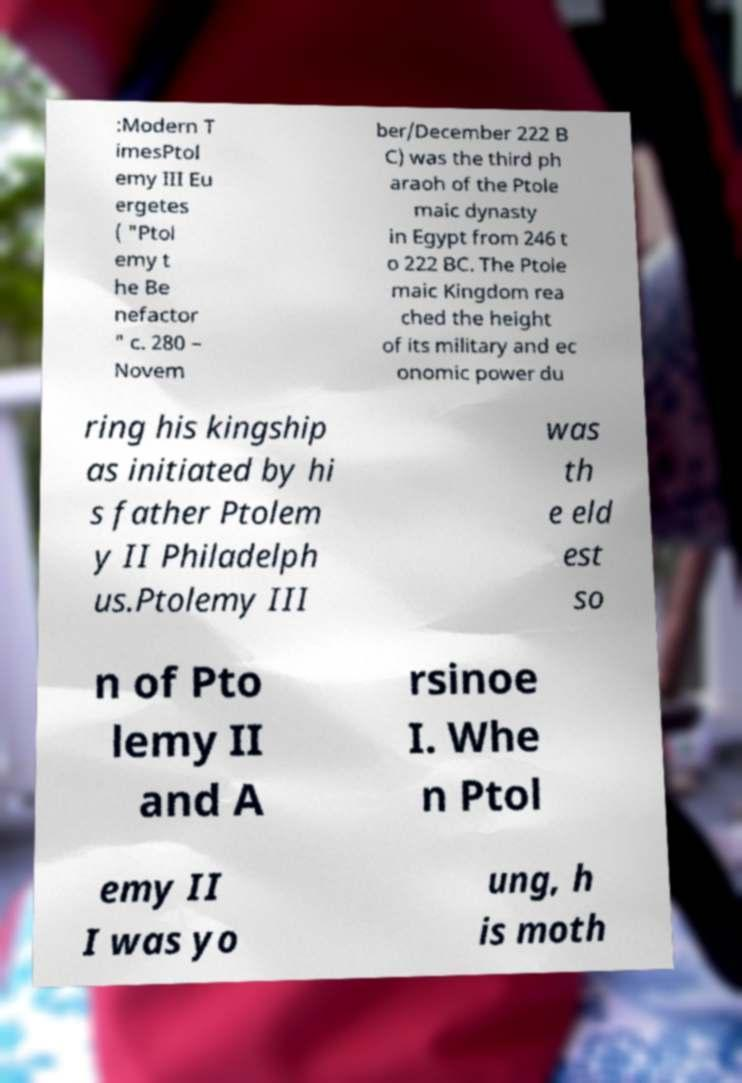What messages or text are displayed in this image? I need them in a readable, typed format. :Modern T imesPtol emy III Eu ergetes ( "Ptol emy t he Be nefactor " c. 280 – Novem ber/December 222 B C) was the third ph araoh of the Ptole maic dynasty in Egypt from 246 t o 222 BC. The Ptole maic Kingdom rea ched the height of its military and ec onomic power du ring his kingship as initiated by hi s father Ptolem y II Philadelph us.Ptolemy III was th e eld est so n of Pto lemy II and A rsinoe I. Whe n Ptol emy II I was yo ung, h is moth 